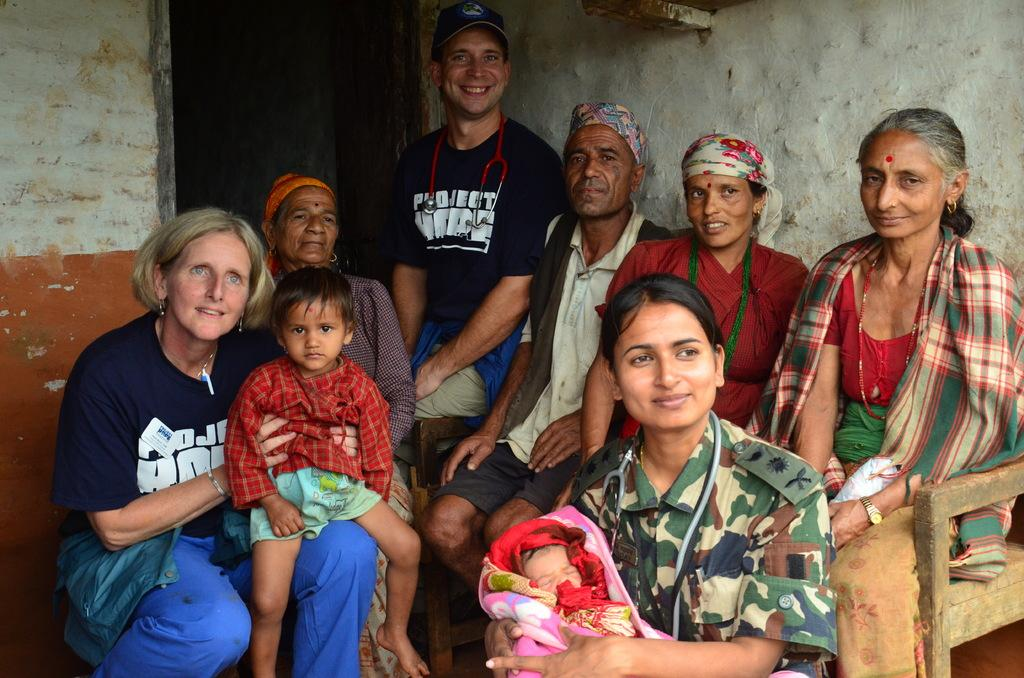What is the general arrangement of the people in the image? There is a group of people in the image, and they are seated. Can you describe the man in the background of the image? The man in the background is smiling and wearing a cap. What objects are associated with the people in the image? There are stethoscopes present in the image. What type of blood is visible on the table in the image? There is no table or blood present in the image. Can you describe the beetle crawling on the man's cap in the image? There is no beetle present on the man's cap in the image. 